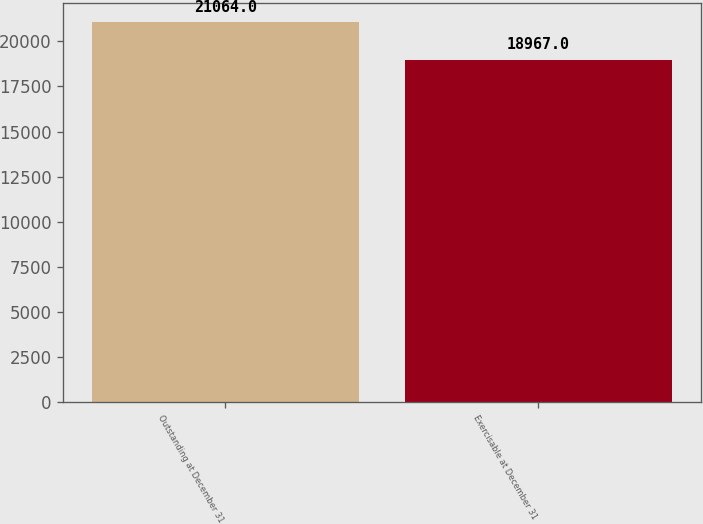<chart> <loc_0><loc_0><loc_500><loc_500><bar_chart><fcel>Outstanding at December 31<fcel>Exercisable at December 31<nl><fcel>21064<fcel>18967<nl></chart> 